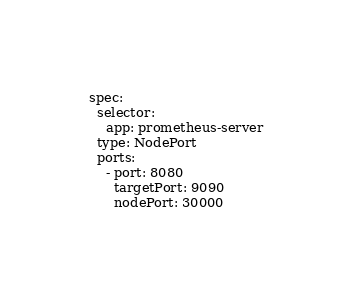<code> <loc_0><loc_0><loc_500><loc_500><_YAML_>spec:
  selector:
    app: prometheus-server
  type: NodePort
  ports:
    - port: 8080
      targetPort: 9090
      nodePort: 30000
</code> 